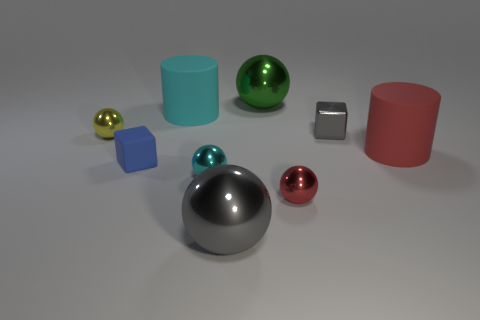There is a small cube that is made of the same material as the red ball; what is its color?
Give a very brief answer. Gray. How many things are metal objects behind the cyan shiny object or yellow objects?
Provide a short and direct response. 3. There is a metal ball that is behind the big cyan rubber object; what is its size?
Offer a very short reply. Large. Do the yellow shiny ball and the gray thing that is on the right side of the large green ball have the same size?
Offer a terse response. Yes. The big metallic sphere that is behind the big cylinder that is on the left side of the cyan metal object is what color?
Your response must be concise. Green. How many other things are the same color as the tiny shiny block?
Your answer should be compact. 1. What size is the blue matte object?
Your answer should be compact. Small. Are there more large green shiny objects on the right side of the large cyan matte cylinder than small yellow balls that are behind the metallic cube?
Your answer should be very brief. Yes. There is a red ball left of the tiny gray object; what number of small gray metallic things are on the right side of it?
Make the answer very short. 1. There is a matte thing that is to the right of the cyan sphere; does it have the same shape as the cyan matte object?
Offer a very short reply. Yes. 